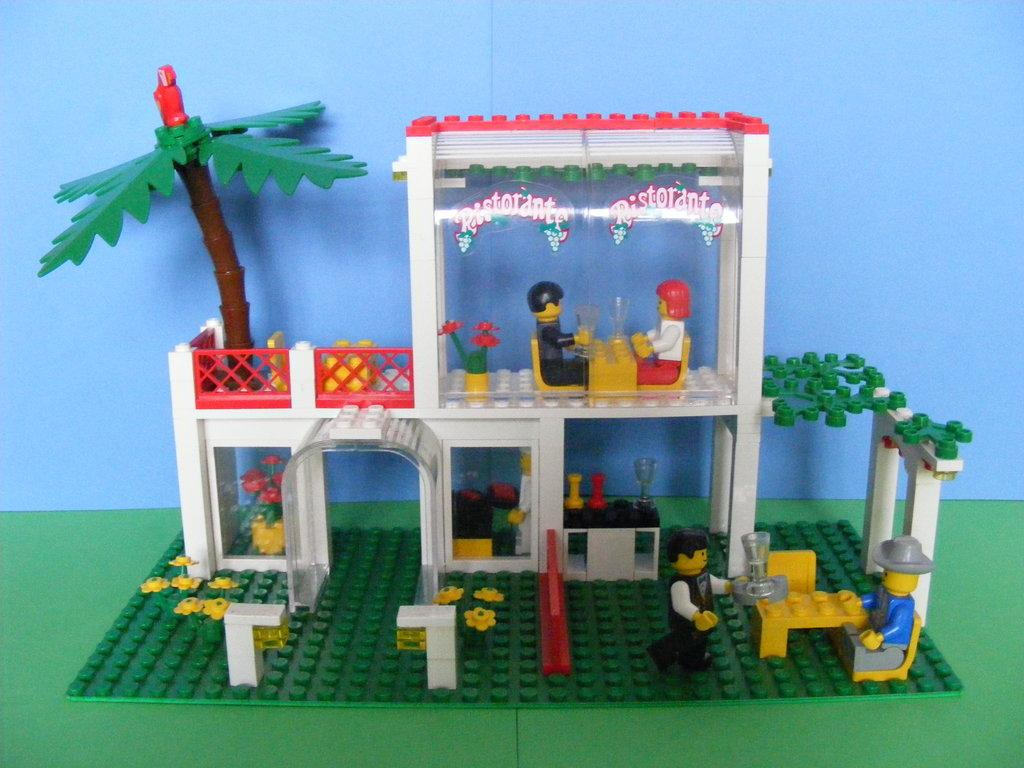What type of establishment is depicted in the image? There is a toy restaurant in the image. Are there any people present in the image? Yes, there are people in the image. What piece of furniture can be seen in the image? There is a table in the image. What type of plant is visible in the image? There is a tree in the image. What color is the floor in the image? The floor in the image is green. What color is the background of the image? The background of the image is blue. Where can the pocket be found in the image? There is no pocket present in the image. Are there any icicles hanging from the tree in the image? There are no icicles visible in the image; it is a toy restaurant with a tree, not an actual outdoor scene. Can you see any dinosaurs in the image? There are no dinosaurs present in the image; it features a toy restaurant with people, a table, a tree, and a green floor. 